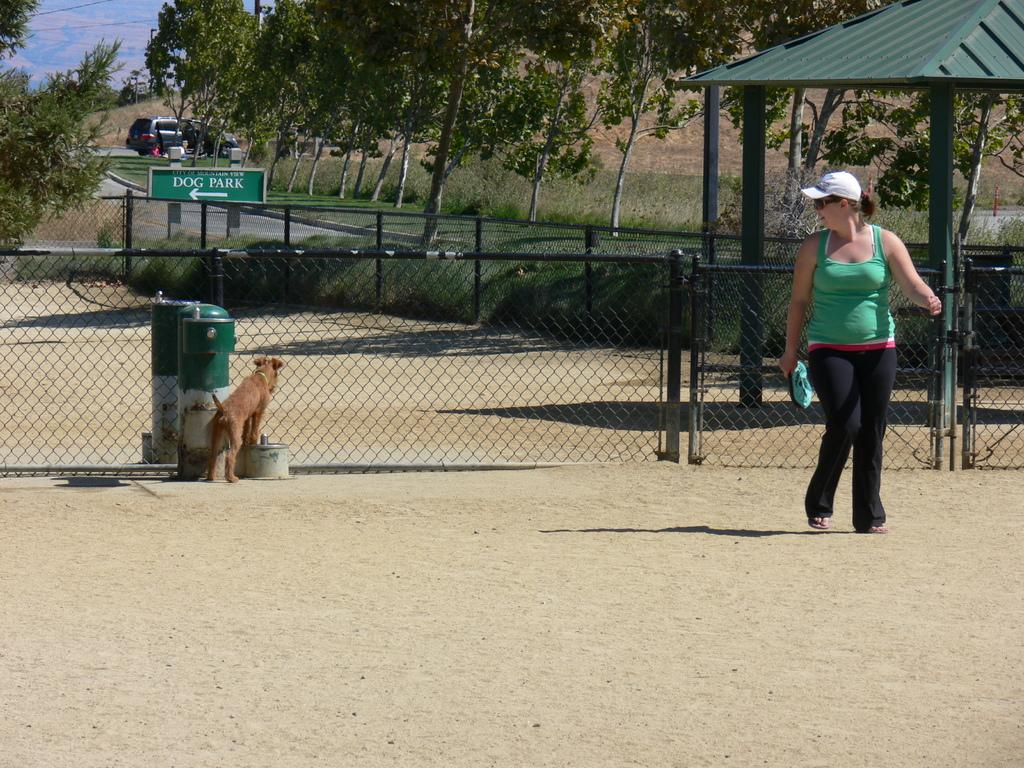What are the women in the image doing? The women in the image are walking. What animal is present in the image? There is a dog standing in the image. What type of structures can be seen in the image? There are fences and a shed in the image. What type of signage is visible in the image? There are sign boards in the image. What mode of transportation is present in the image? There are motor vehicles on the road in the image. What type of vegetation is present can be seen in the image? There are trees and grass in the image. What is visible in the sky in the image? The sky is visible in the image, and there are clouds in the sky. What type of steel is used to construct the donkey in the image? There is no donkey present in the image, and therefore no steel construction can be observed. How many visitors are visible in the image? There is no mention of visitors in the image, so it cannot be determined how many are present. 